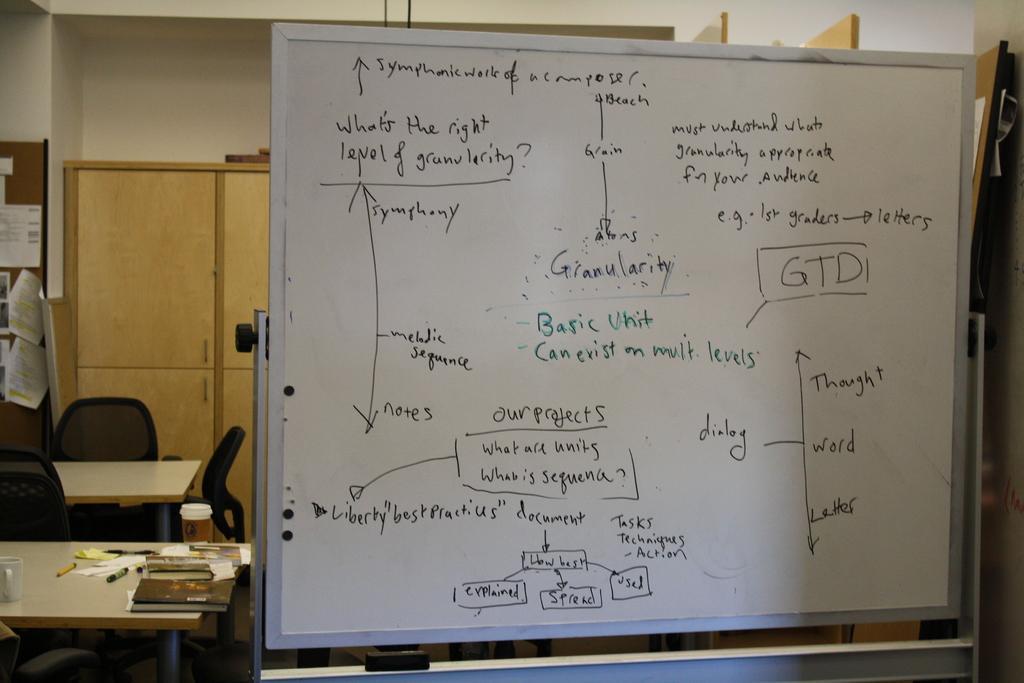In one or two sentences, can you explain what this image depicts? In this picture there is a whiteboard. There is a table,pen and a cup on a table. There is a chair. There is a desk and a paper. 